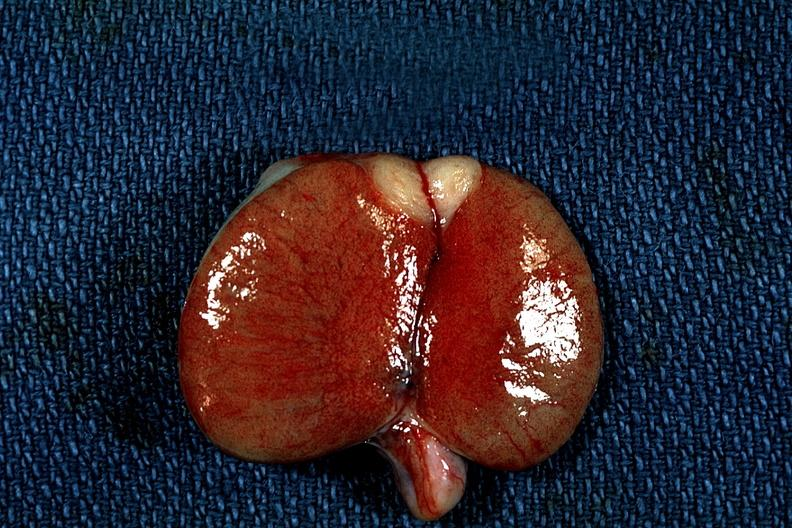s cut edge of mesentery present?
Answer the question using a single word or phrase. No 